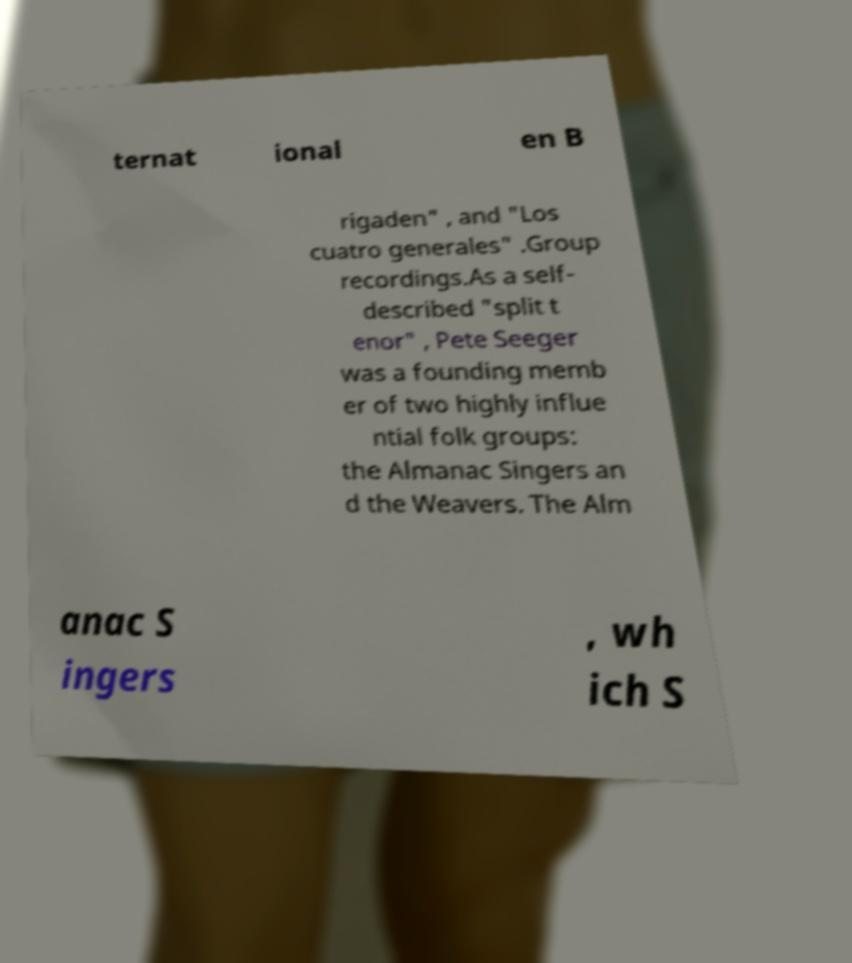Could you extract and type out the text from this image? ternat ional en B rigaden" , and "Los cuatro generales" .Group recordings.As a self- described "split t enor" , Pete Seeger was a founding memb er of two highly influe ntial folk groups: the Almanac Singers an d the Weavers. The Alm anac S ingers , wh ich S 